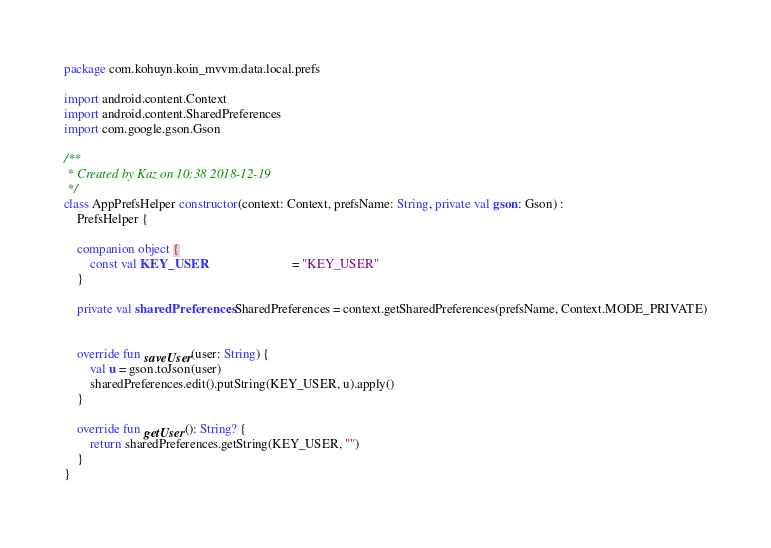<code> <loc_0><loc_0><loc_500><loc_500><_Kotlin_>package com.kohuyn.koin_mvvm.data.local.prefs

import android.content.Context
import android.content.SharedPreferences
import com.google.gson.Gson

/**
 * Created by Kaz on 10:38 2018-12-19
 */
class AppPrefsHelper constructor(context: Context, prefsName: String, private val gson: Gson) :
    PrefsHelper {

    companion object {
        const val KEY_USER                          = "KEY_USER"
    }

    private val sharedPreferences: SharedPreferences = context.getSharedPreferences(prefsName, Context.MODE_PRIVATE)


    override fun saveUser(user: String) {
        val u = gson.toJson(user)
        sharedPreferences.edit().putString(KEY_USER, u).apply()
    }

    override fun getUser(): String? {
        return sharedPreferences.getString(KEY_USER, "")
    }
}</code> 